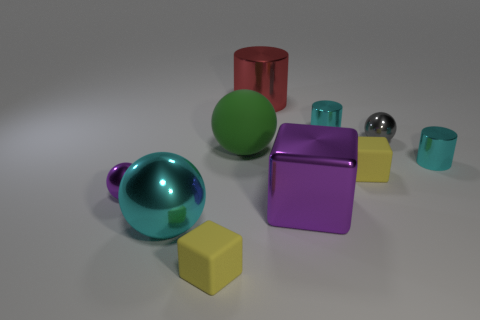There is a big rubber thing that is the same shape as the large cyan metal object; what is its color?
Your answer should be very brief. Green. Are there the same number of tiny cyan metal things in front of the large metal ball and big purple balls?
Your response must be concise. Yes. How many yellow rubber cubes are both left of the large purple metallic object and right of the red cylinder?
Your answer should be compact. 0. There is a cyan metallic object that is the same shape as the tiny gray thing; what is its size?
Keep it short and to the point. Large. How many cylinders have the same material as the small gray object?
Your answer should be very brief. 3. Is the number of matte things that are behind the cyan metal ball less than the number of large objects?
Your answer should be compact. Yes. What number of shiny balls are there?
Your answer should be compact. 3. What number of tiny shiny cylinders are the same color as the large metal cylinder?
Give a very brief answer. 0. Is the tiny gray shiny object the same shape as the large cyan object?
Offer a very short reply. Yes. How big is the purple object that is to the right of the yellow matte thing in front of the small purple metal sphere?
Give a very brief answer. Large. 